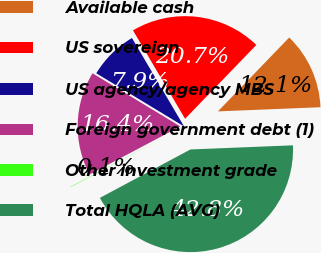Convert chart. <chart><loc_0><loc_0><loc_500><loc_500><pie_chart><fcel>Available cash<fcel>US sovereign<fcel>US agency/agency MBS<fcel>Foreign government debt (1)<fcel>Other investment grade<fcel>Total HQLA (AVG)<nl><fcel>12.14%<fcel>20.69%<fcel>7.86%<fcel>16.42%<fcel>0.06%<fcel>42.83%<nl></chart> 